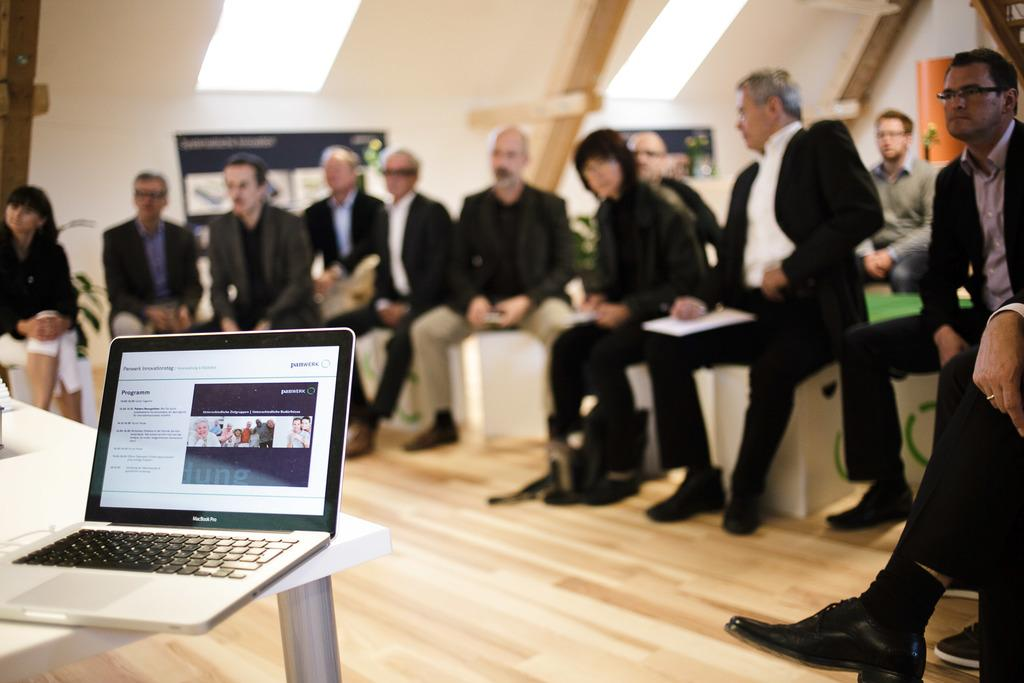What are the people in the image doing? The people in the image are sitting. What electronic device can be seen on a table in the image? There is a laptop on a table in the image. Can you see a trail of footprints leading to the river in the image? There is no trail of footprints or river present in the image. Are the people in the image wearing masks? There is no indication of people wearing masks in the image. 